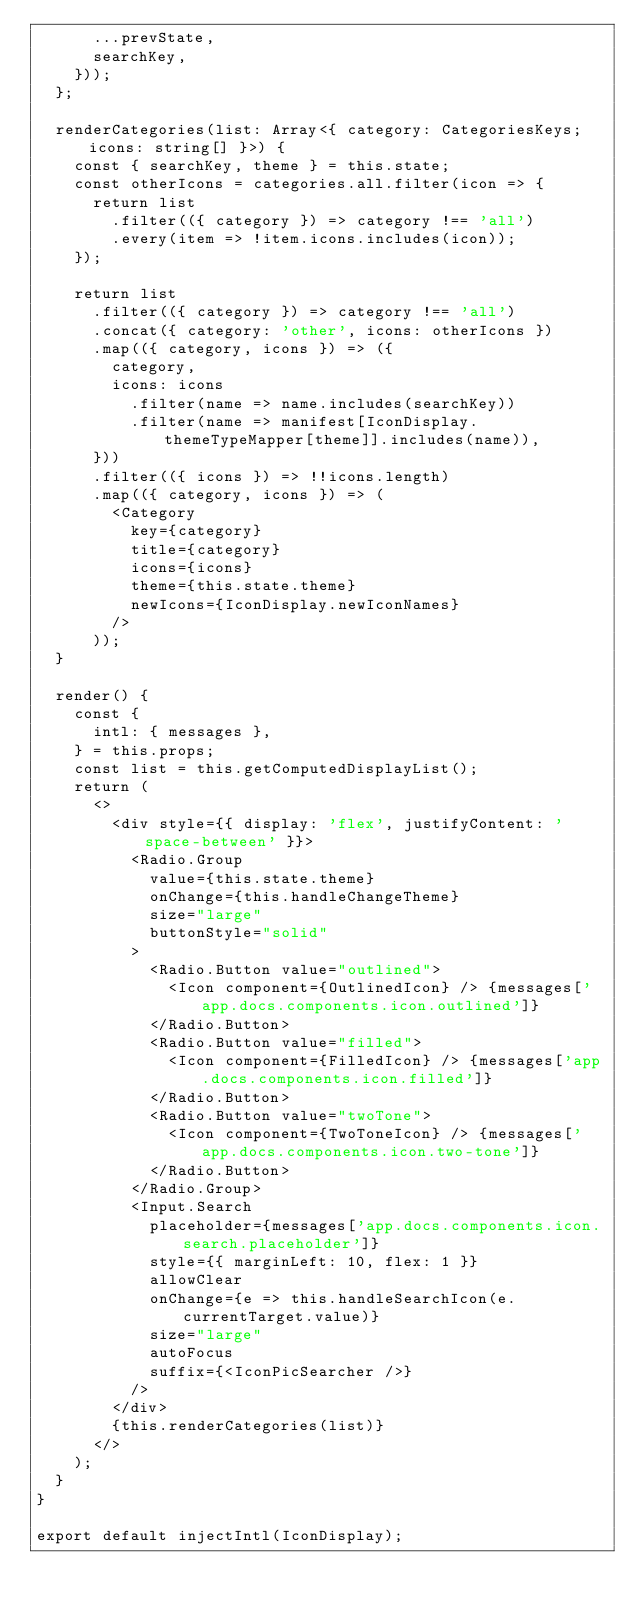<code> <loc_0><loc_0><loc_500><loc_500><_TypeScript_>      ...prevState,
      searchKey,
    }));
  };

  renderCategories(list: Array<{ category: CategoriesKeys; icons: string[] }>) {
    const { searchKey, theme } = this.state;
    const otherIcons = categories.all.filter(icon => {
      return list
        .filter(({ category }) => category !== 'all')
        .every(item => !item.icons.includes(icon));
    });

    return list
      .filter(({ category }) => category !== 'all')
      .concat({ category: 'other', icons: otherIcons })
      .map(({ category, icons }) => ({
        category,
        icons: icons
          .filter(name => name.includes(searchKey))
          .filter(name => manifest[IconDisplay.themeTypeMapper[theme]].includes(name)),
      }))
      .filter(({ icons }) => !!icons.length)
      .map(({ category, icons }) => (
        <Category
          key={category}
          title={category}
          icons={icons}
          theme={this.state.theme}
          newIcons={IconDisplay.newIconNames}
        />
      ));
  }

  render() {
    const {
      intl: { messages },
    } = this.props;
    const list = this.getComputedDisplayList();
    return (
      <>
        <div style={{ display: 'flex', justifyContent: 'space-between' }}>
          <Radio.Group
            value={this.state.theme}
            onChange={this.handleChangeTheme}
            size="large"
            buttonStyle="solid"
          >
            <Radio.Button value="outlined">
              <Icon component={OutlinedIcon} /> {messages['app.docs.components.icon.outlined']}
            </Radio.Button>
            <Radio.Button value="filled">
              <Icon component={FilledIcon} /> {messages['app.docs.components.icon.filled']}
            </Radio.Button>
            <Radio.Button value="twoTone">
              <Icon component={TwoToneIcon} /> {messages['app.docs.components.icon.two-tone']}
            </Radio.Button>
          </Radio.Group>
          <Input.Search
            placeholder={messages['app.docs.components.icon.search.placeholder']}
            style={{ marginLeft: 10, flex: 1 }}
            allowClear
            onChange={e => this.handleSearchIcon(e.currentTarget.value)}
            size="large"
            autoFocus
            suffix={<IconPicSearcher />}
          />
        </div>
        {this.renderCategories(list)}
      </>
    );
  }
}

export default injectIntl(IconDisplay);
</code> 